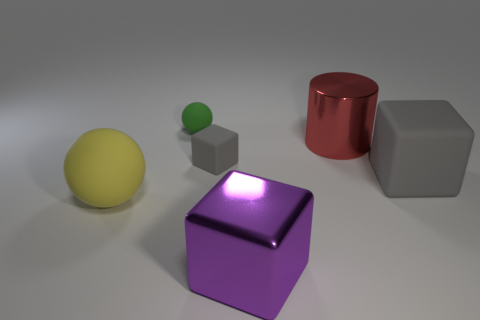Are there any other things that have the same shape as the red metallic thing?
Give a very brief answer. No. The green object that is the same shape as the large yellow matte object is what size?
Make the answer very short. Small. What shape is the gray matte object right of the big shiny cube?
Your response must be concise. Cube. What material is the small thing that is the same color as the large rubber block?
Offer a terse response. Rubber. How many other spheres are the same size as the yellow rubber sphere?
Make the answer very short. 0. The large block that is the same material as the green ball is what color?
Your response must be concise. Gray. Are there fewer tiny green metallic blocks than large yellow objects?
Give a very brief answer. Yes. How many blue things are either tiny cubes or big rubber spheres?
Your answer should be compact. 0. What number of large objects are both in front of the large red cylinder and on the right side of the small green matte object?
Your answer should be compact. 2. Is the large sphere made of the same material as the green object?
Offer a terse response. Yes. 